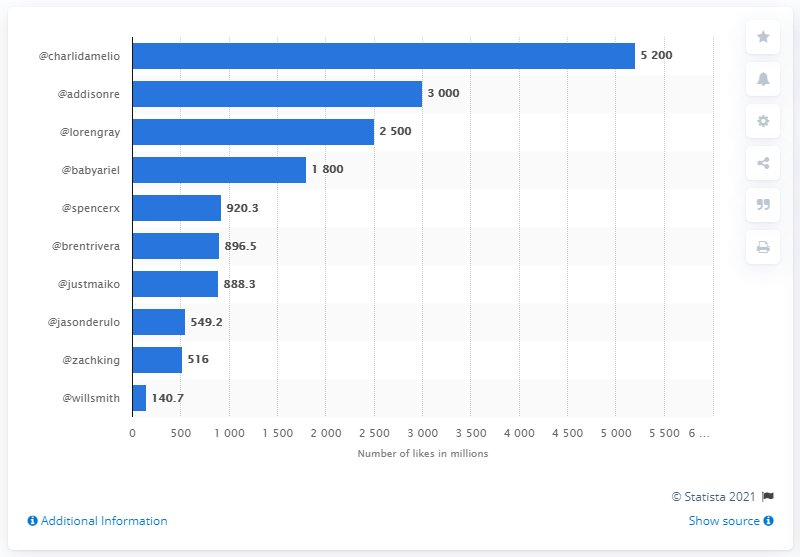How many likes did Charli D'Amelio have on her content? Based on the bar chart, Charli D'Amelio had approximately 5200 million likes on her content, which translates to about 5.2 billion likes. 